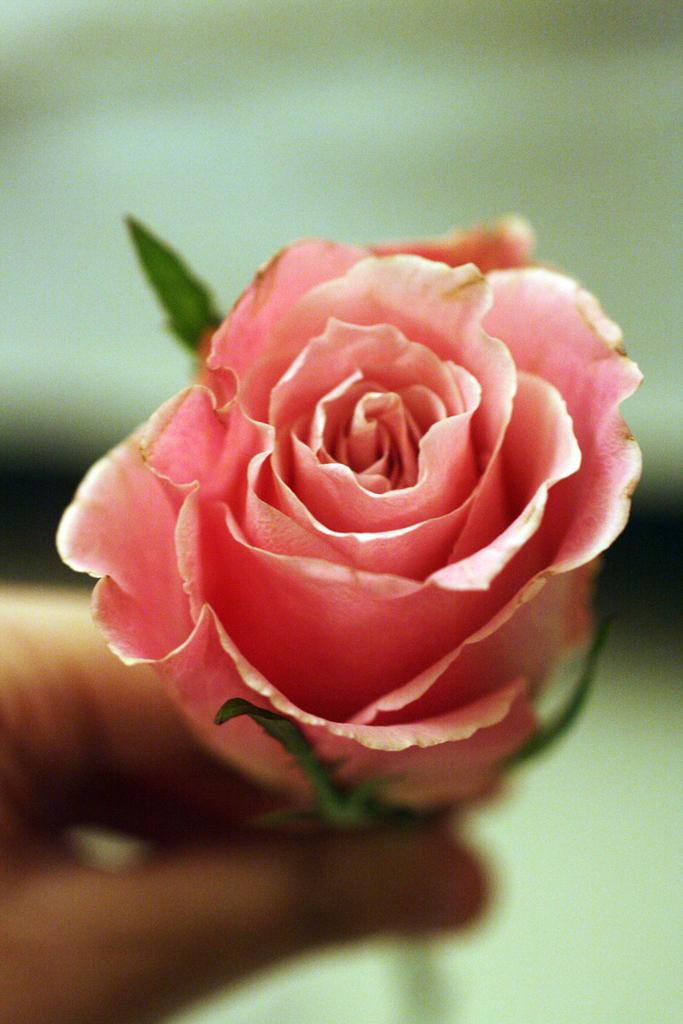What is the person holding in the image? There is a person's hand holding a flower in the image. Can you describe the background of the image? The background of the image is blurred. Who is the person's mom in the image? There is no person's mom present in the image, as only a hand holding a flower is visible. How many sheep can be seen in the image? There are no sheep present in the image. 